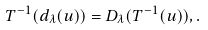<formula> <loc_0><loc_0><loc_500><loc_500>T ^ { - 1 } ( d _ { \lambda } ( u ) ) = D _ { \lambda } ( T ^ { - 1 } ( u ) ) , .</formula> 